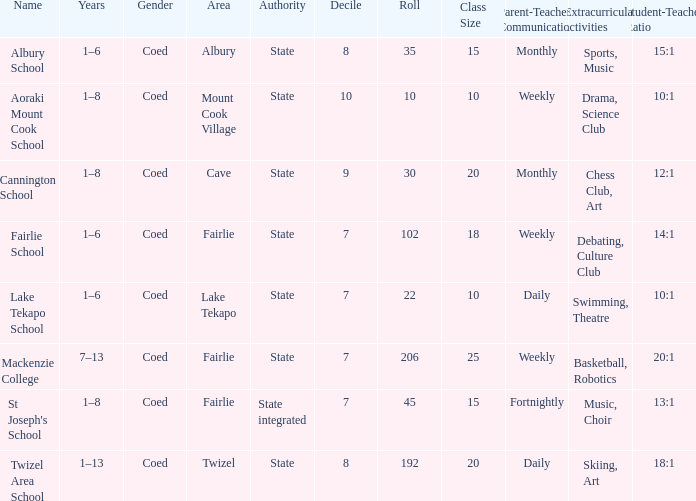What area is named Mackenzie college? Fairlie. Can you give me this table as a dict? {'header': ['Name', 'Years', 'Gender', 'Area', 'Authority', 'Decile', 'Roll', 'Class Size', 'Parent-Teacher Communication', 'Extracurricular activities', 'Student-Teacher Ratio '], 'rows': [['Albury School', '1–6', 'Coed', 'Albury', 'State', '8', '35', '15', 'Monthly', 'Sports, Music', '15:1'], ['Aoraki Mount Cook School', '1–8', 'Coed', 'Mount Cook Village', 'State', '10', '10', '10', 'Weekly', 'Drama, Science Club', '10:1'], ['Cannington School', '1–8', 'Coed', 'Cave', 'State', '9', '30', '20', 'Monthly', 'Chess Club, Art', '12:1'], ['Fairlie School', '1–6', 'Coed', 'Fairlie', 'State', '7', '102', '18', 'Weekly', 'Debating, Culture Club', '14:1'], ['Lake Tekapo School', '1–6', 'Coed', 'Lake Tekapo', 'State', '7', '22', '10', 'Daily', 'Swimming, Theatre', '10:1'], ['Mackenzie College', '7–13', 'Coed', 'Fairlie', 'State', '7', '206', '25', 'Weekly', 'Basketball, Robotics', '20:1'], ["St Joseph's School", '1–8', 'Coed', 'Fairlie', 'State integrated', '7', '45', '15', 'Fortnightly', 'Music, Choir', '13:1'], ['Twizel Area School', '1–13', 'Coed', 'Twizel', 'State', '8', '192', '20', 'Daily', 'Skiing, Art', '18:1']]} 